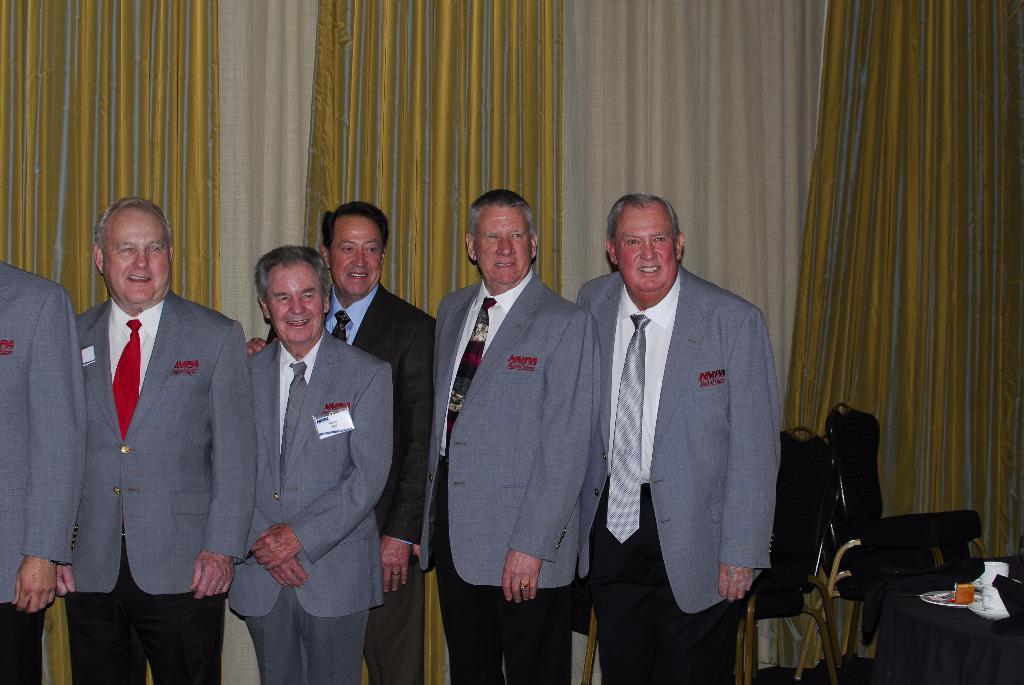In one or two sentences, can you explain what this image depicts? In this image we can see few people standing, there are few chairs, a table covered with cloth and few objects on the table and curtains in the background. 